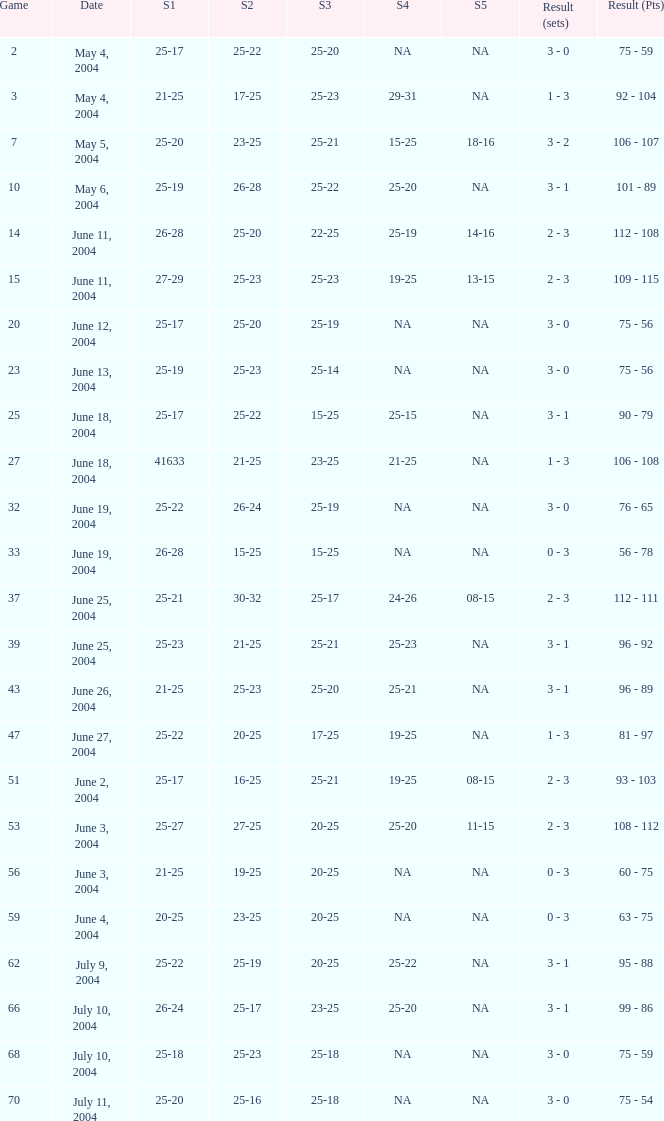What is the set 5 for the game with a set 2 of 21-25 and a set 1 of 41633? NA. Parse the full table. {'header': ['Game', 'Date', 'S1', 'S2', 'S3', 'S4', 'S5', 'Result (sets)', 'Result (Pts)'], 'rows': [['2', 'May 4, 2004', '25-17', '25-22', '25-20', 'NA', 'NA', '3 - 0', '75 - 59'], ['3', 'May 4, 2004', '21-25', '17-25', '25-23', '29-31', 'NA', '1 - 3', '92 - 104'], ['7', 'May 5, 2004', '25-20', '23-25', '25-21', '15-25', '18-16', '3 - 2', '106 - 107'], ['10', 'May 6, 2004', '25-19', '26-28', '25-22', '25-20', 'NA', '3 - 1', '101 - 89'], ['14', 'June 11, 2004', '26-28', '25-20', '22-25', '25-19', '14-16', '2 - 3', '112 - 108'], ['15', 'June 11, 2004', '27-29', '25-23', '25-23', '19-25', '13-15', '2 - 3', '109 - 115'], ['20', 'June 12, 2004', '25-17', '25-20', '25-19', 'NA', 'NA', '3 - 0', '75 - 56'], ['23', 'June 13, 2004', '25-19', '25-23', '25-14', 'NA', 'NA', '3 - 0', '75 - 56'], ['25', 'June 18, 2004', '25-17', '25-22', '15-25', '25-15', 'NA', '3 - 1', '90 - 79'], ['27', 'June 18, 2004', '41633', '21-25', '23-25', '21-25', 'NA', '1 - 3', '106 - 108'], ['32', 'June 19, 2004', '25-22', '26-24', '25-19', 'NA', 'NA', '3 - 0', '76 - 65'], ['33', 'June 19, 2004', '26-28', '15-25', '15-25', 'NA', 'NA', '0 - 3', '56 - 78'], ['37', 'June 25, 2004', '25-21', '30-32', '25-17', '24-26', '08-15', '2 - 3', '112 - 111'], ['39', 'June 25, 2004', '25-23', '21-25', '25-21', '25-23', 'NA', '3 - 1', '96 - 92'], ['43', 'June 26, 2004', '21-25', '25-23', '25-20', '25-21', 'NA', '3 - 1', '96 - 89'], ['47', 'June 27, 2004', '25-22', '20-25', '17-25', '19-25', 'NA', '1 - 3', '81 - 97'], ['51', 'June 2, 2004', '25-17', '16-25', '25-21', '19-25', '08-15', '2 - 3', '93 - 103'], ['53', 'June 3, 2004', '25-27', '27-25', '20-25', '25-20', '11-15', '2 - 3', '108 - 112'], ['56', 'June 3, 2004', '21-25', '19-25', '20-25', 'NA', 'NA', '0 - 3', '60 - 75'], ['59', 'June 4, 2004', '20-25', '23-25', '20-25', 'NA', 'NA', '0 - 3', '63 - 75'], ['62', 'July 9, 2004', '25-22', '25-19', '20-25', '25-22', 'NA', '3 - 1', '95 - 88'], ['66', 'July 10, 2004', '26-24', '25-17', '23-25', '25-20', 'NA', '3 - 1', '99 - 86'], ['68', 'July 10, 2004', '25-18', '25-23', '25-18', 'NA', 'NA', '3 - 0', '75 - 59'], ['70', 'July 11, 2004', '25-20', '25-16', '25-18', 'NA', 'NA', '3 - 0', '75 - 54']]} 